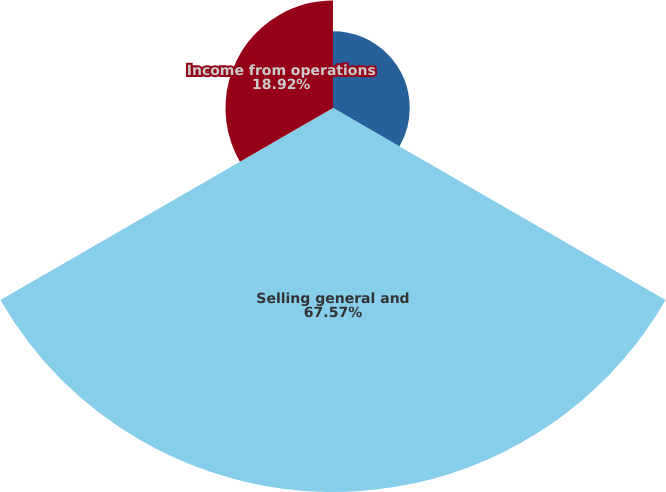Convert chart to OTSL. <chart><loc_0><loc_0><loc_500><loc_500><pie_chart><fcel>Research and development<fcel>Selling general and<fcel>Income from operations<nl><fcel>13.51%<fcel>67.57%<fcel>18.92%<nl></chart> 